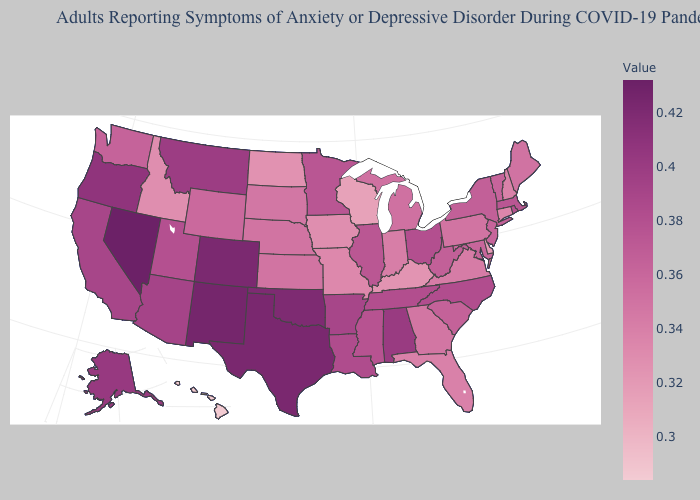Does Texas have a lower value than Alabama?
Be succinct. No. Does Nevada have the highest value in the USA?
Keep it brief. Yes. Does Nevada have the highest value in the USA?
Quick response, please. Yes. Does Colorado have the lowest value in the USA?
Keep it brief. No. Among the states that border Michigan , does Indiana have the lowest value?
Answer briefly. No. Does Connecticut have the highest value in the USA?
Quick response, please. No. Does Hawaii have the lowest value in the USA?
Concise answer only. Yes. 